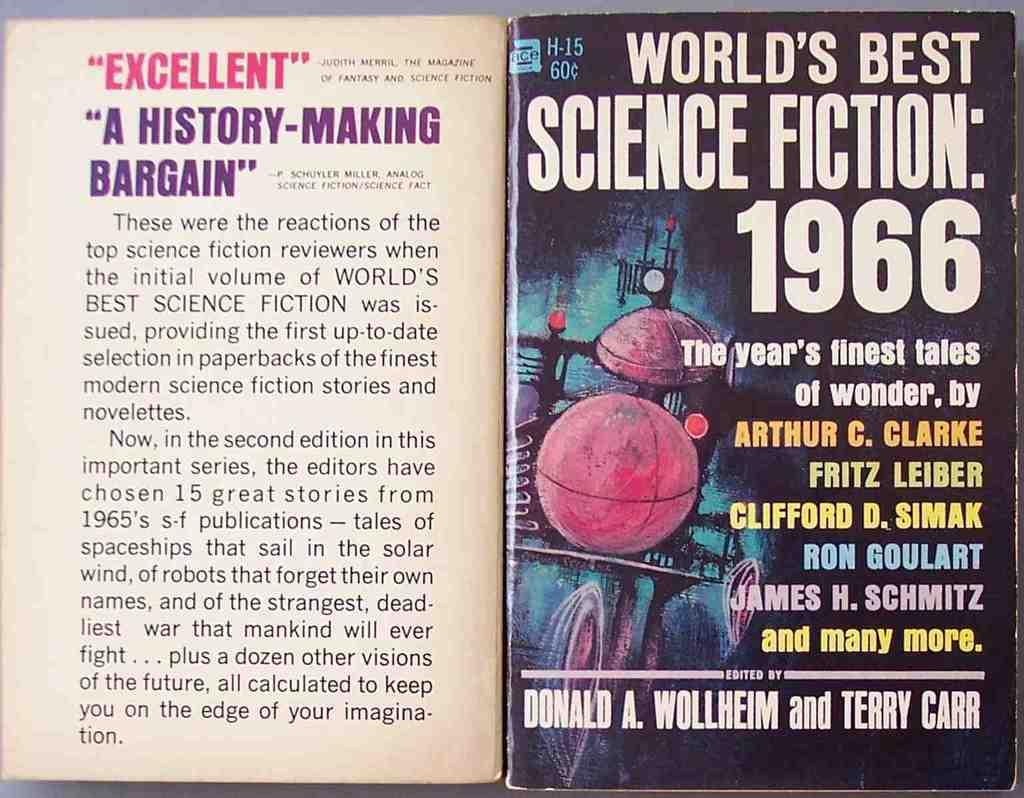<image>
Offer a succinct explanation of the picture presented. A paperback featuring science fiction stories from 1966. 